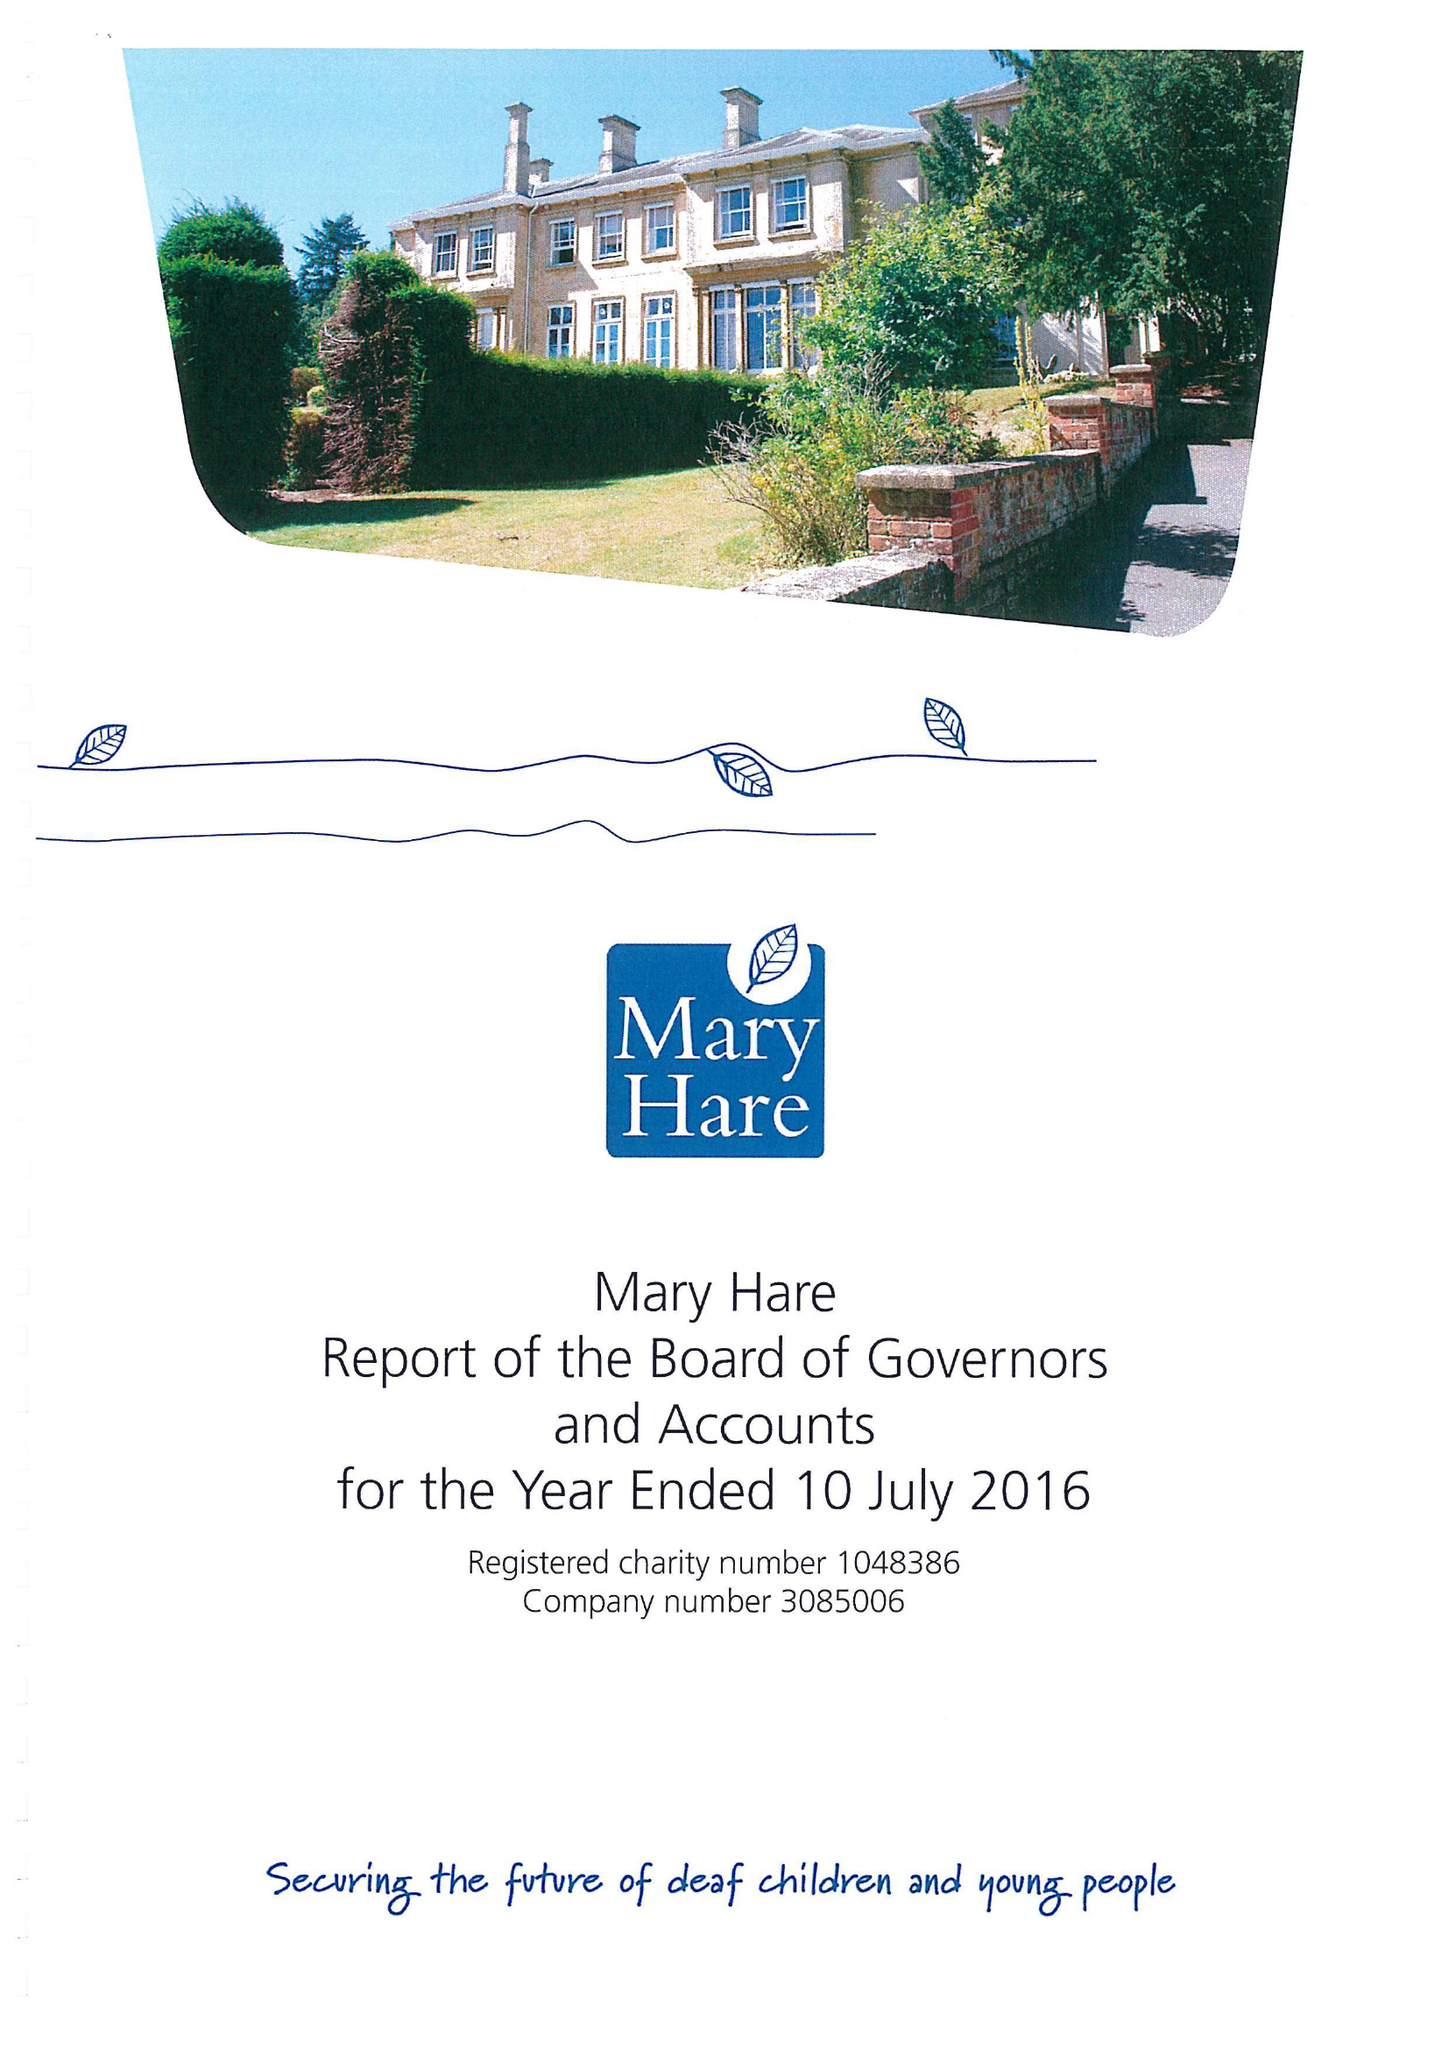What is the value for the spending_annually_in_british_pounds?
Answer the question using a single word or phrase. 11356000.00 